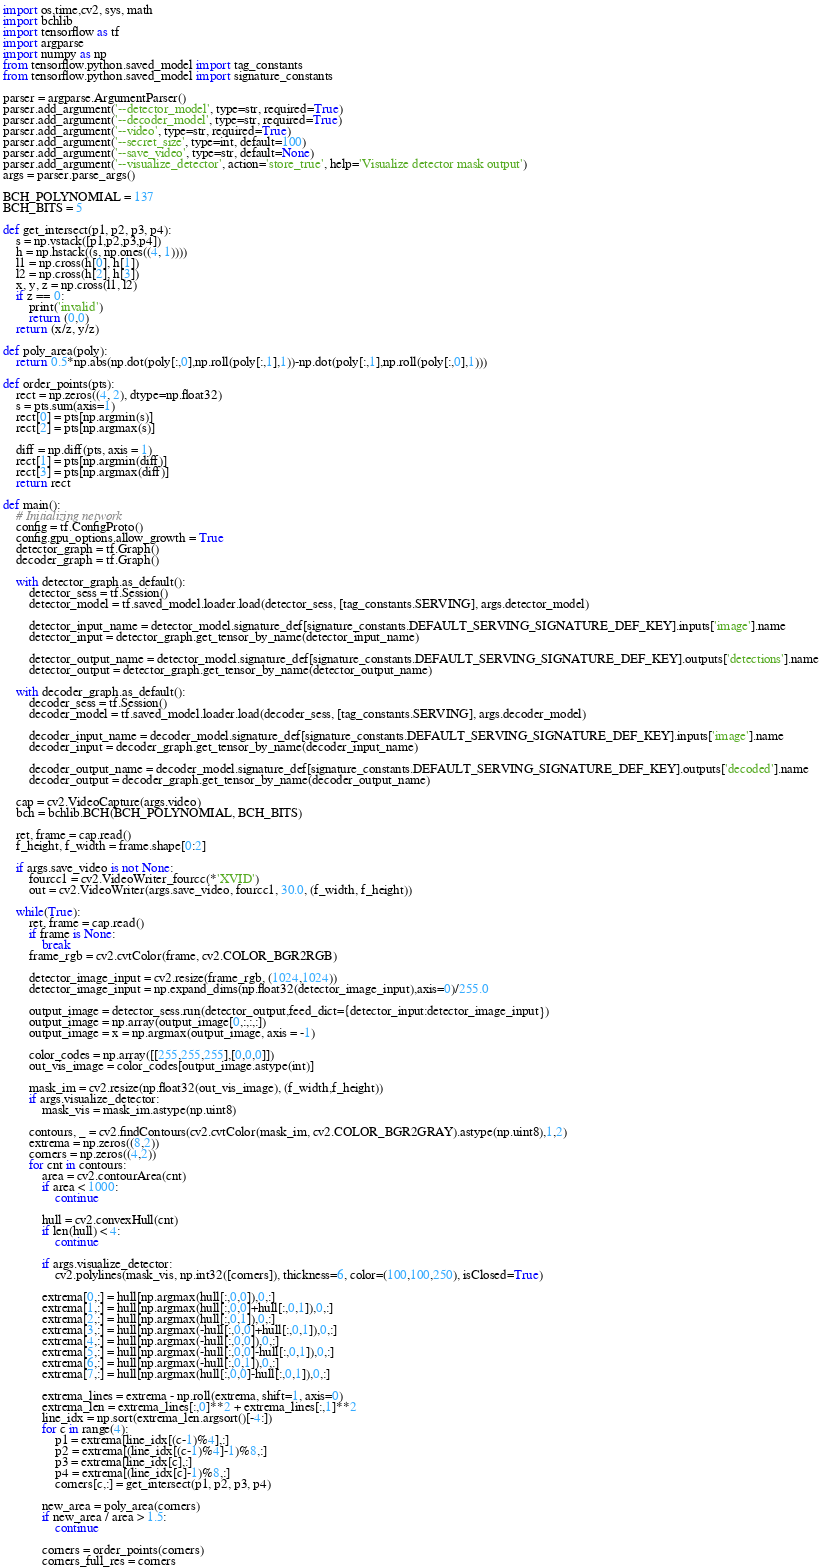<code> <loc_0><loc_0><loc_500><loc_500><_Python_>import os,time,cv2, sys, math
import bchlib
import tensorflow as tf
import argparse
import numpy as np
from tensorflow.python.saved_model import tag_constants
from tensorflow.python.saved_model import signature_constants

parser = argparse.ArgumentParser()
parser.add_argument('--detector_model', type=str, required=True)
parser.add_argument('--decoder_model', type=str, required=True)
parser.add_argument('--video', type=str, required=True)
parser.add_argument('--secret_size', type=int, default=100)
parser.add_argument('--save_video', type=str, default=None)
parser.add_argument('--visualize_detector', action='store_true', help='Visualize detector mask output')
args = parser.parse_args()

BCH_POLYNOMIAL = 137
BCH_BITS = 5

def get_intersect(p1, p2, p3, p4):
    s = np.vstack([p1,p2,p3,p4])
    h = np.hstack((s, np.ones((4, 1))))
    l1 = np.cross(h[0], h[1])
    l2 = np.cross(h[2], h[3])
    x, y, z = np.cross(l1, l2)
    if z == 0:
        print('invalid')
        return (0,0)
    return (x/z, y/z)

def poly_area(poly):
    return 0.5*np.abs(np.dot(poly[:,0],np.roll(poly[:,1],1))-np.dot(poly[:,1],np.roll(poly[:,0],1)))

def order_points(pts):
    rect = np.zeros((4, 2), dtype=np.float32)
    s = pts.sum(axis=1)
    rect[0] = pts[np.argmin(s)]
    rect[2] = pts[np.argmax(s)]

    diff = np.diff(pts, axis = 1)
    rect[1] = pts[np.argmin(diff)]
    rect[3] = pts[np.argmax(diff)]
    return rect

def main():
    # Initializing network
    config = tf.ConfigProto()
    config.gpu_options.allow_growth = True
    detector_graph = tf.Graph()
    decoder_graph = tf.Graph()

    with detector_graph.as_default():
        detector_sess = tf.Session()
        detector_model = tf.saved_model.loader.load(detector_sess, [tag_constants.SERVING], args.detector_model)

        detector_input_name = detector_model.signature_def[signature_constants.DEFAULT_SERVING_SIGNATURE_DEF_KEY].inputs['image'].name
        detector_input = detector_graph.get_tensor_by_name(detector_input_name)

        detector_output_name = detector_model.signature_def[signature_constants.DEFAULT_SERVING_SIGNATURE_DEF_KEY].outputs['detections'].name
        detector_output = detector_graph.get_tensor_by_name(detector_output_name)

    with decoder_graph.as_default():
        decoder_sess = tf.Session()
        decoder_model = tf.saved_model.loader.load(decoder_sess, [tag_constants.SERVING], args.decoder_model)

        decoder_input_name = decoder_model.signature_def[signature_constants.DEFAULT_SERVING_SIGNATURE_DEF_KEY].inputs['image'].name
        decoder_input = decoder_graph.get_tensor_by_name(decoder_input_name)

        decoder_output_name = decoder_model.signature_def[signature_constants.DEFAULT_SERVING_SIGNATURE_DEF_KEY].outputs['decoded'].name
        decoder_output = decoder_graph.get_tensor_by_name(decoder_output_name)

    cap = cv2.VideoCapture(args.video)
    bch = bchlib.BCH(BCH_POLYNOMIAL, BCH_BITS)

    ret, frame = cap.read()
    f_height, f_width = frame.shape[0:2]

    if args.save_video is not None:
        fourcc1 = cv2.VideoWriter_fourcc(*'XVID')
        out = cv2.VideoWriter(args.save_video, fourcc1, 30.0, (f_width, f_height))

    while(True):
        ret, frame = cap.read()
        if frame is None:
            break
        frame_rgb = cv2.cvtColor(frame, cv2.COLOR_BGR2RGB)

        detector_image_input = cv2.resize(frame_rgb, (1024,1024))
        detector_image_input = np.expand_dims(np.float32(detector_image_input),axis=0)/255.0

        output_image = detector_sess.run(detector_output,feed_dict={detector_input:detector_image_input})
        output_image = np.array(output_image[0,:,:,:])
        output_image = x = np.argmax(output_image, axis = -1)

        color_codes = np.array([[255,255,255],[0,0,0]])
        out_vis_image = color_codes[output_image.astype(int)]

        mask_im = cv2.resize(np.float32(out_vis_image), (f_width,f_height))
        if args.visualize_detector:
            mask_vis = mask_im.astype(np.uint8)

        contours, _ = cv2.findContours(cv2.cvtColor(mask_im, cv2.COLOR_BGR2GRAY).astype(np.uint8),1,2)
        extrema = np.zeros((8,2))
        corners = np.zeros((4,2))
        for cnt in contours:
            area = cv2.contourArea(cnt)
            if area < 1000:
                continue

            hull = cv2.convexHull(cnt)
            if len(hull) < 4:
                continue

            if args.visualize_detector:
                cv2.polylines(mask_vis, np.int32([corners]), thickness=6, color=(100,100,250), isClosed=True)

            extrema[0,:] = hull[np.argmax(hull[:,0,0]),0,:]
            extrema[1,:] = hull[np.argmax(hull[:,0,0]+hull[:,0,1]),0,:]
            extrema[2,:] = hull[np.argmax(hull[:,0,1]),0,:]
            extrema[3,:] = hull[np.argmax(-hull[:,0,0]+hull[:,0,1]),0,:]
            extrema[4,:] = hull[np.argmax(-hull[:,0,0]),0,:]
            extrema[5,:] = hull[np.argmax(-hull[:,0,0]-hull[:,0,1]),0,:]
            extrema[6,:] = hull[np.argmax(-hull[:,0,1]),0,:]
            extrema[7,:] = hull[np.argmax(hull[:,0,0]-hull[:,0,1]),0,:]

            extrema_lines = extrema - np.roll(extrema, shift=1, axis=0)
            extrema_len = extrema_lines[:,0]**2 + extrema_lines[:,1]**2
            line_idx = np.sort(extrema_len.argsort()[-4:])
            for c in range(4):
                p1 = extrema[line_idx[(c-1)%4],:]
                p2 = extrema[(line_idx[(c-1)%4]-1)%8,:]
                p3 = extrema[line_idx[c],:]
                p4 = extrema[(line_idx[c]-1)%8,:]
                corners[c,:] = get_intersect(p1, p2, p3, p4)

            new_area = poly_area(corners)
            if new_area / area > 1.5:
                continue

            corners = order_points(corners)
            corners_full_res = corners
</code> 